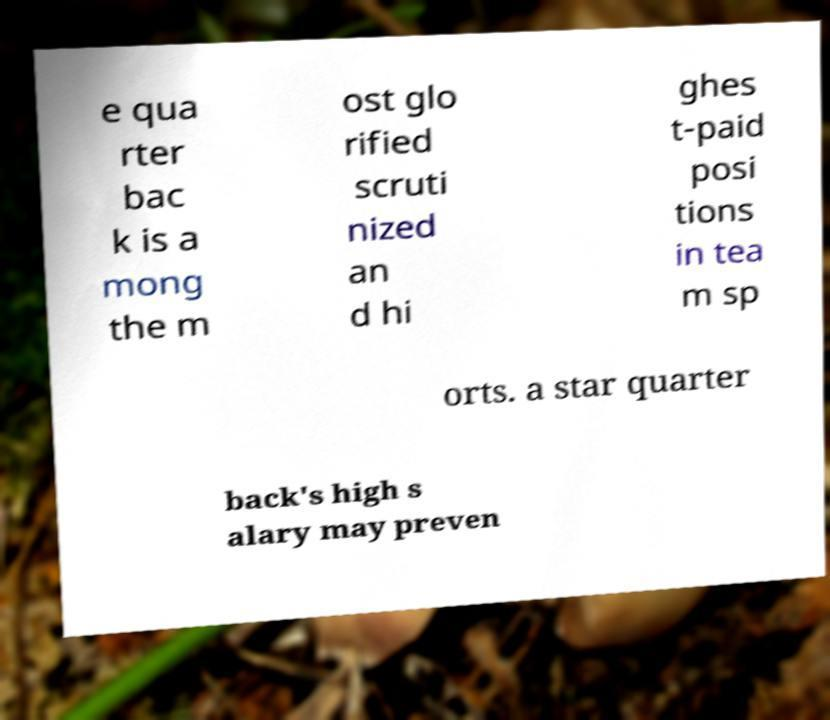Please read and relay the text visible in this image. What does it say? e qua rter bac k is a mong the m ost glo rified scruti nized an d hi ghes t-paid posi tions in tea m sp orts. a star quarter back's high s alary may preven 